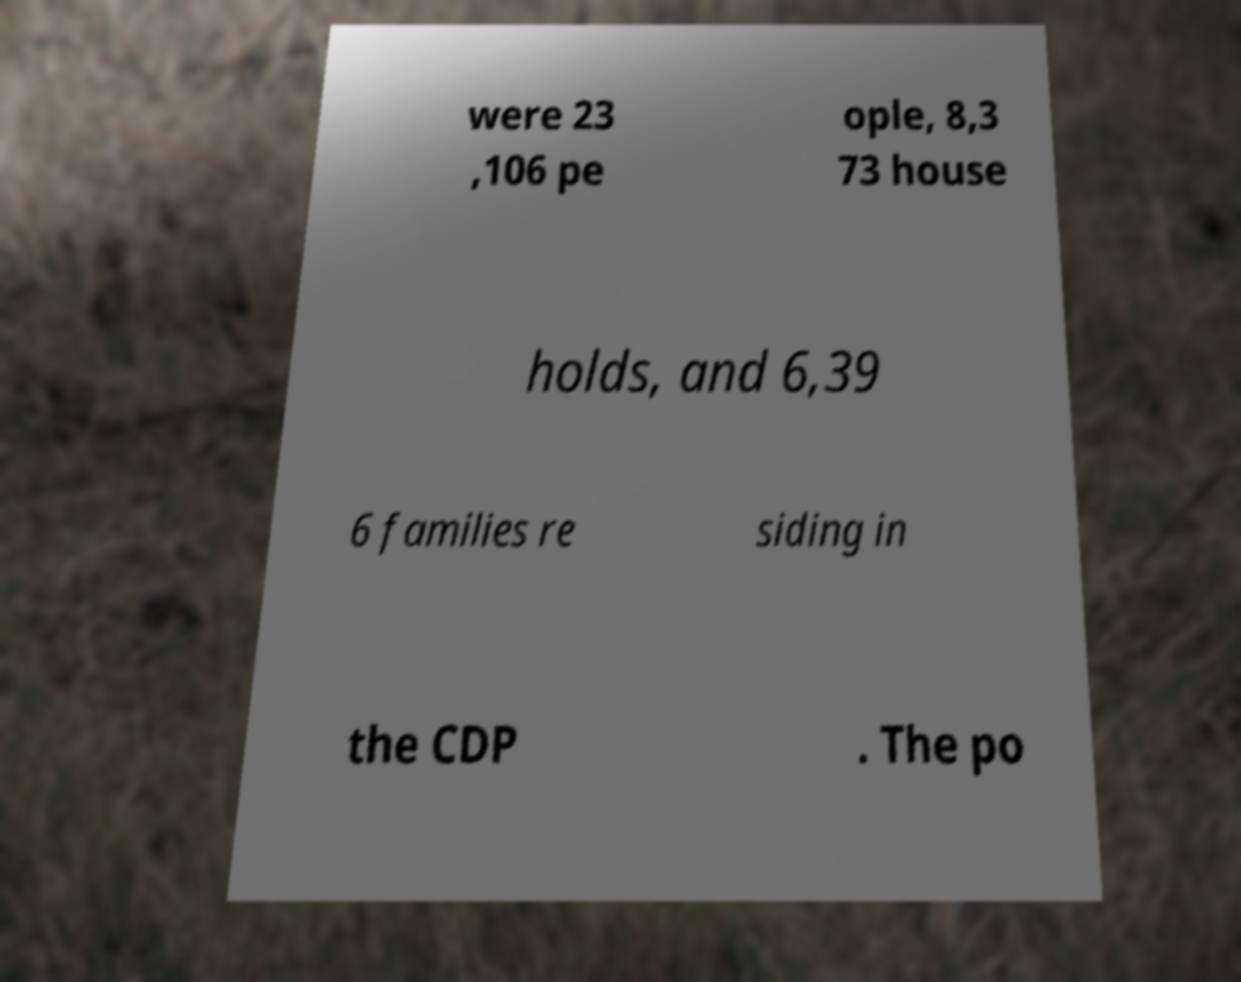I need the written content from this picture converted into text. Can you do that? were 23 ,106 pe ople, 8,3 73 house holds, and 6,39 6 families re siding in the CDP . The po 